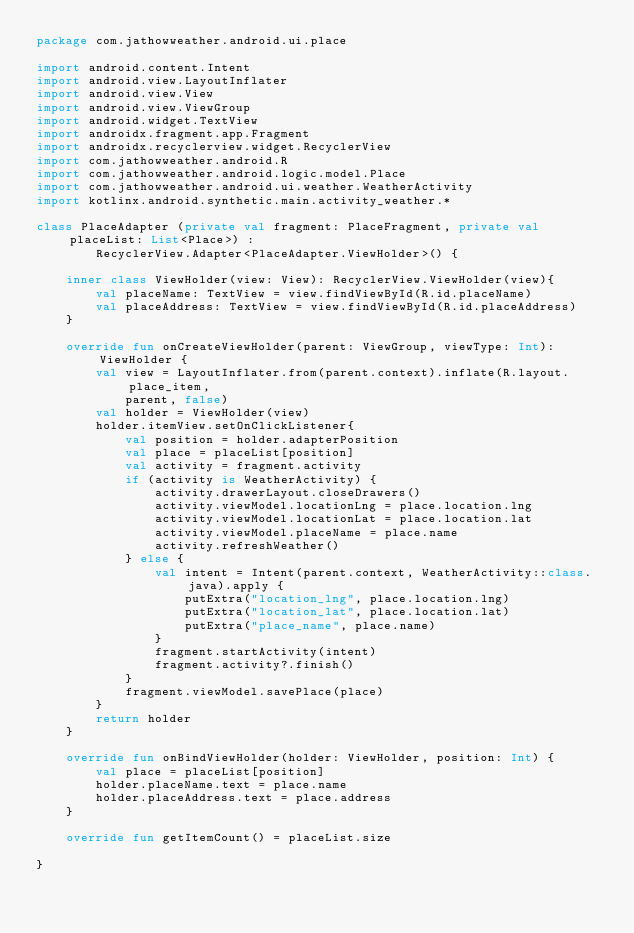<code> <loc_0><loc_0><loc_500><loc_500><_Kotlin_>package com.jathowweather.android.ui.place

import android.content.Intent
import android.view.LayoutInflater
import android.view.View
import android.view.ViewGroup
import android.widget.TextView
import androidx.fragment.app.Fragment
import androidx.recyclerview.widget.RecyclerView
import com.jathowweather.android.R
import com.jathowweather.android.logic.model.Place
import com.jathowweather.android.ui.weather.WeatherActivity
import kotlinx.android.synthetic.main.activity_weather.*

class PlaceAdapter (private val fragment: PlaceFragment, private val placeList: List<Place>) :
        RecyclerView.Adapter<PlaceAdapter.ViewHolder>() {

    inner class ViewHolder(view: View): RecyclerView.ViewHolder(view){
        val placeName: TextView = view.findViewById(R.id.placeName)
        val placeAddress: TextView = view.findViewById(R.id.placeAddress)
    }

    override fun onCreateViewHolder(parent: ViewGroup, viewType: Int): ViewHolder {
        val view = LayoutInflater.from(parent.context).inflate(R.layout.place_item,
            parent, false)
        val holder = ViewHolder(view)
        holder.itemView.setOnClickListener{
            val position = holder.adapterPosition
            val place = placeList[position]
            val activity = fragment.activity
            if (activity is WeatherActivity) {
                activity.drawerLayout.closeDrawers()
                activity.viewModel.locationLng = place.location.lng
                activity.viewModel.locationLat = place.location.lat
                activity.viewModel.placeName = place.name
                activity.refreshWeather()
            } else {
                val intent = Intent(parent.context, WeatherActivity::class.java).apply {
                    putExtra("location_lng", place.location.lng)
                    putExtra("location_lat", place.location.lat)
                    putExtra("place_name", place.name)
                }
                fragment.startActivity(intent)
                fragment.activity?.finish()
            }
            fragment.viewModel.savePlace(place)
        }
        return holder
    }

    override fun onBindViewHolder(holder: ViewHolder, position: Int) {
        val place = placeList[position]
        holder.placeName.text = place.name
        holder.placeAddress.text = place.address
    }

    override fun getItemCount() = placeList.size

}</code> 